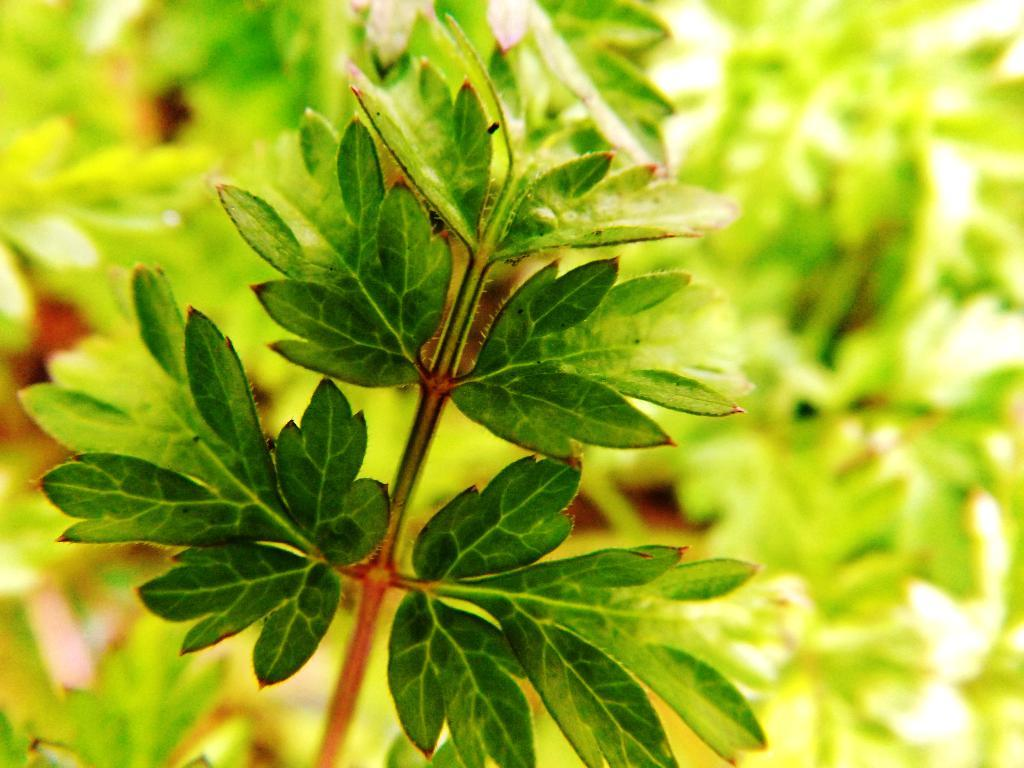What type of living organisms can be seen in the image? Plants can be seen in the image. What color are the leaves of the plants in the foreground? The leaves in the foreground of the image are green. How does the pollution affect the plants in the image? There is no indication of pollution in the image, so it cannot be determined how it might affect the plants. 